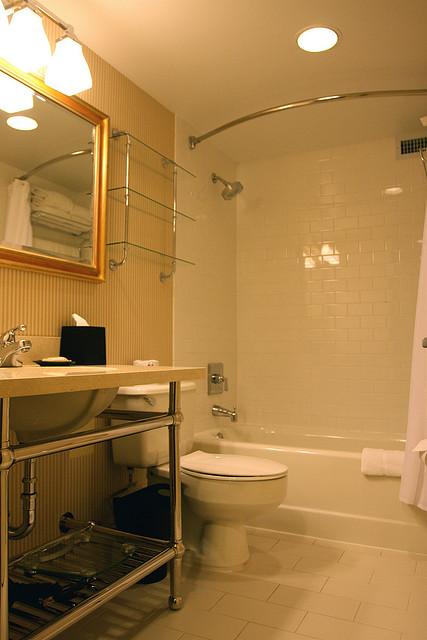Is the shower rod straight or curved?
Answer briefly. Curved. Is this a hotel bathroom?
Be succinct. No. Which room is this?
Give a very brief answer. Bathroom. What is the color of the toilet?
Answer briefly. White. 